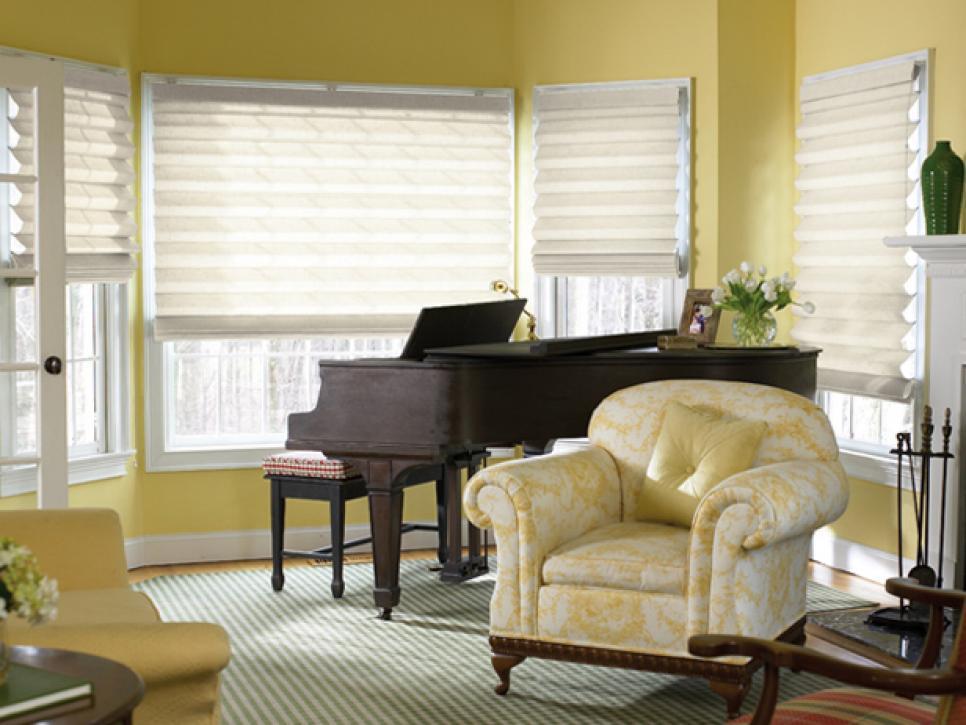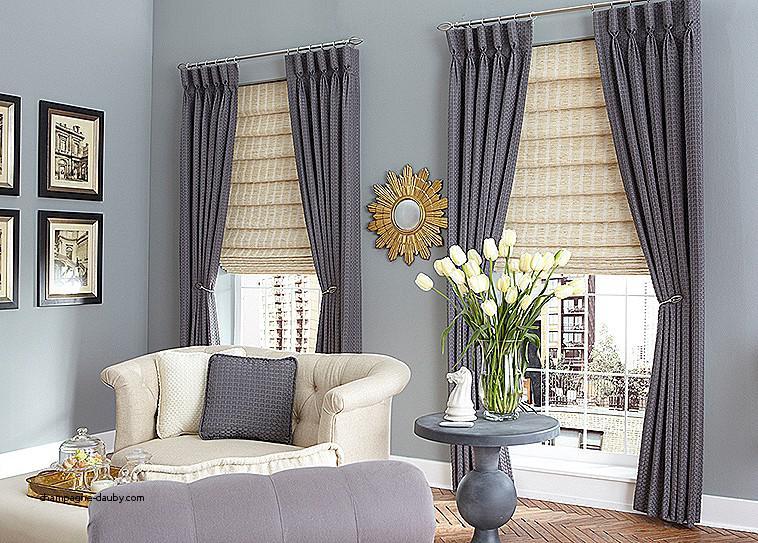The first image is the image on the left, the second image is the image on the right. For the images shown, is this caption "The right image contains two windows with gray curtains." true? Answer yes or no. Yes. 